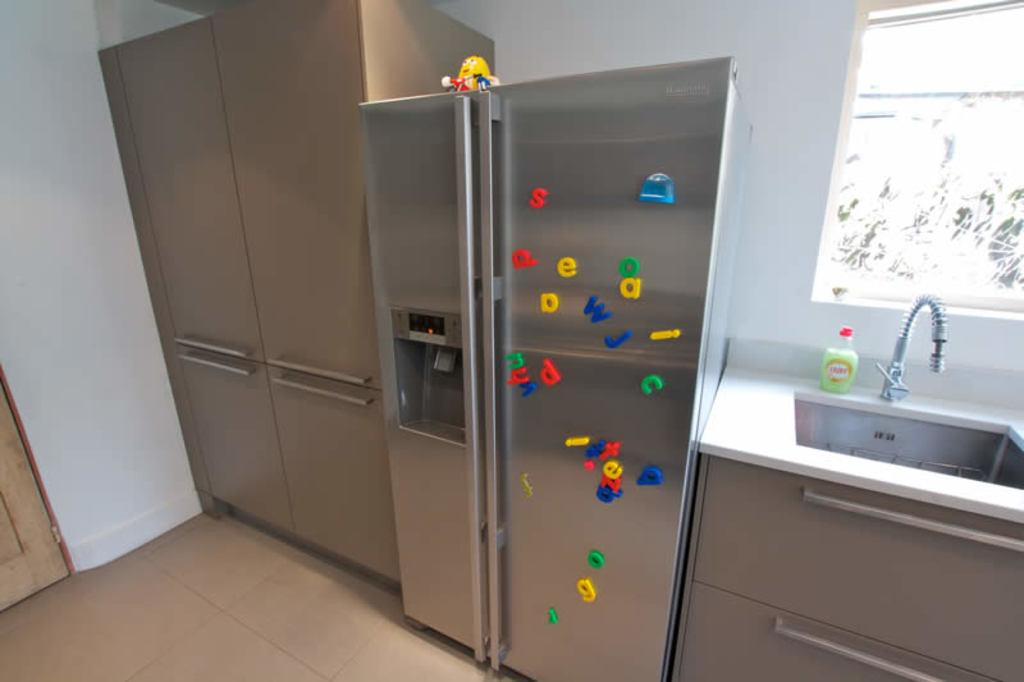What type of appliance can be seen in the image? There is a refrigerator present in the image. What can be found near the refrigerator? There is a tap with a basin near the refrigerator. What architectural feature is visible in the image? There is a door in the image. What type of background is visible in the image? There is a wall visible in the image. What type of ornament is hanging from the refrigerator in the image? There is no ornament hanging from the refrigerator in the image. What is the mass of the door in the image? The mass of the door cannot be determined from the image alone. 